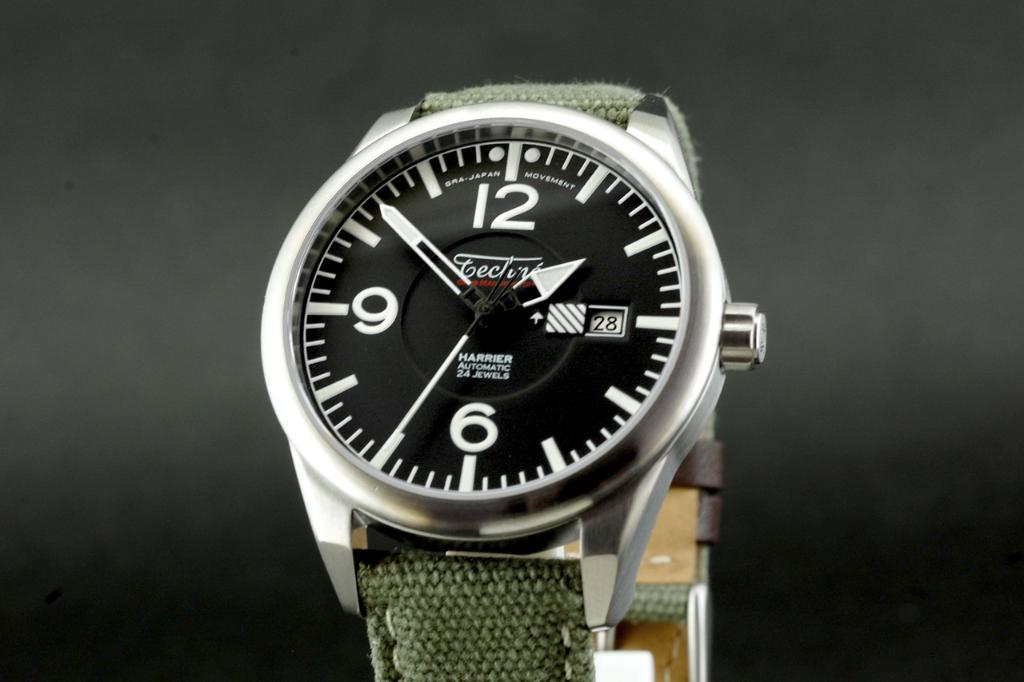<image>
Create a compact narrative representing the image presented. Today is the 28th according to my new watch. 